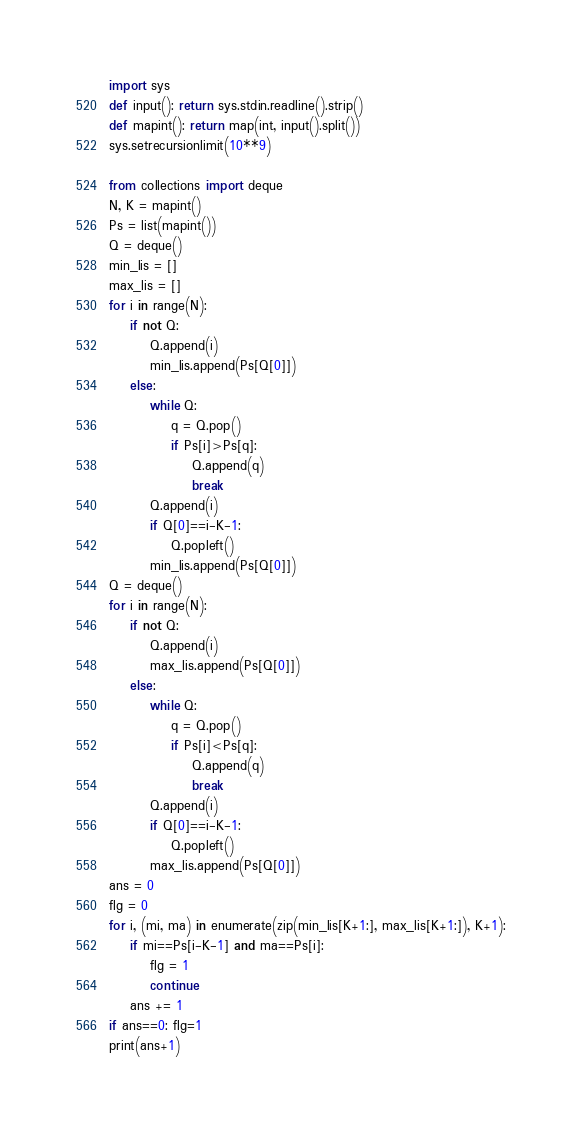Convert code to text. <code><loc_0><loc_0><loc_500><loc_500><_Python_>import sys
def input(): return sys.stdin.readline().strip()
def mapint(): return map(int, input().split())
sys.setrecursionlimit(10**9)
 
from collections import deque
N, K = mapint()
Ps = list(mapint())
Q = deque()
min_lis = []
max_lis = []
for i in range(N):
    if not Q:
        Q.append(i)
        min_lis.append(Ps[Q[0]])
    else:
        while Q:
            q = Q.pop()
            if Ps[i]>Ps[q]:
                Q.append(q)
                break
        Q.append(i)
        if Q[0]==i-K-1:
            Q.popleft()
        min_lis.append(Ps[Q[0]])
Q = deque()
for i in range(N):
    if not Q:
        Q.append(i)
        max_lis.append(Ps[Q[0]])
    else:
        while Q:
            q = Q.pop()
            if Ps[i]<Ps[q]:
                Q.append(q)
                break
        Q.append(i)
        if Q[0]==i-K-1:
            Q.popleft()
        max_lis.append(Ps[Q[0]])
ans = 0
flg = 0
for i, (mi, ma) in enumerate(zip(min_lis[K+1:], max_lis[K+1:]), K+1):
    if mi==Ps[i-K-1] and ma==Ps[i]:
        flg = 1
        continue
    ans += 1
if ans==0: flg=1
print(ans+1)</code> 